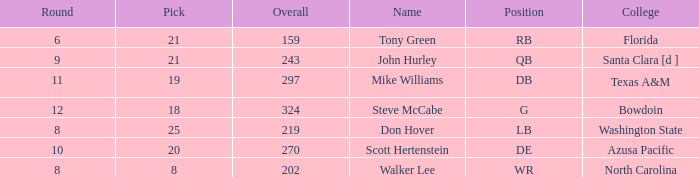What college has an overall less than 243, and tony green as the name? Florida. 